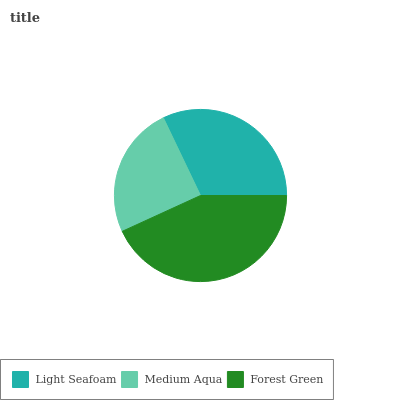Is Medium Aqua the minimum?
Answer yes or no. Yes. Is Forest Green the maximum?
Answer yes or no. Yes. Is Forest Green the minimum?
Answer yes or no. No. Is Medium Aqua the maximum?
Answer yes or no. No. Is Forest Green greater than Medium Aqua?
Answer yes or no. Yes. Is Medium Aqua less than Forest Green?
Answer yes or no. Yes. Is Medium Aqua greater than Forest Green?
Answer yes or no. No. Is Forest Green less than Medium Aqua?
Answer yes or no. No. Is Light Seafoam the high median?
Answer yes or no. Yes. Is Light Seafoam the low median?
Answer yes or no. Yes. Is Forest Green the high median?
Answer yes or no. No. Is Forest Green the low median?
Answer yes or no. No. 